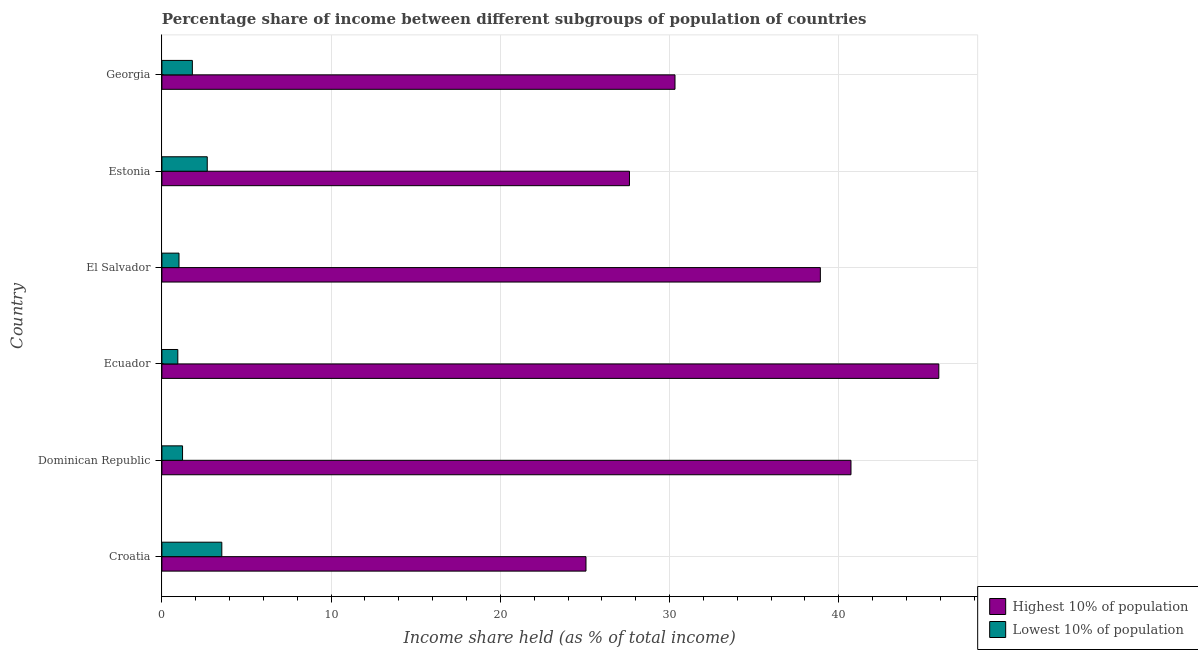How many different coloured bars are there?
Provide a succinct answer. 2. How many groups of bars are there?
Your answer should be very brief. 6. Are the number of bars per tick equal to the number of legend labels?
Keep it short and to the point. Yes. Are the number of bars on each tick of the Y-axis equal?
Provide a short and direct response. Yes. How many bars are there on the 3rd tick from the bottom?
Make the answer very short. 2. What is the label of the 4th group of bars from the top?
Keep it short and to the point. Ecuador. What is the income share held by highest 10% of the population in Estonia?
Keep it short and to the point. 27.63. Across all countries, what is the maximum income share held by highest 10% of the population?
Make the answer very short. 45.91. Across all countries, what is the minimum income share held by lowest 10% of the population?
Your answer should be very brief. 0.94. In which country was the income share held by lowest 10% of the population maximum?
Provide a succinct answer. Croatia. In which country was the income share held by highest 10% of the population minimum?
Ensure brevity in your answer.  Croatia. What is the total income share held by highest 10% of the population in the graph?
Offer a terse response. 208.55. What is the difference between the income share held by lowest 10% of the population in Ecuador and that in El Salvador?
Make the answer very short. -0.07. What is the difference between the income share held by highest 10% of the population in Estonia and the income share held by lowest 10% of the population in El Salvador?
Provide a short and direct response. 26.62. What is the average income share held by lowest 10% of the population per country?
Your response must be concise. 1.86. What is the difference between the income share held by lowest 10% of the population and income share held by highest 10% of the population in El Salvador?
Provide a succinct answer. -37.9. What is the ratio of the income share held by lowest 10% of the population in Ecuador to that in Estonia?
Provide a succinct answer. 0.35. Is the income share held by highest 10% of the population in Croatia less than that in Dominican Republic?
Ensure brevity in your answer.  Yes. Is the difference between the income share held by highest 10% of the population in Croatia and Ecuador greater than the difference between the income share held by lowest 10% of the population in Croatia and Ecuador?
Your answer should be compact. No. What is the difference between the highest and the second highest income share held by highest 10% of the population?
Provide a succinct answer. 5.19. What is the difference between the highest and the lowest income share held by lowest 10% of the population?
Provide a succinct answer. 2.6. Is the sum of the income share held by lowest 10% of the population in Dominican Republic and Georgia greater than the maximum income share held by highest 10% of the population across all countries?
Make the answer very short. No. What does the 2nd bar from the top in Georgia represents?
Provide a short and direct response. Highest 10% of population. What does the 1st bar from the bottom in Dominican Republic represents?
Provide a short and direct response. Highest 10% of population. What is the difference between two consecutive major ticks on the X-axis?
Your answer should be compact. 10. Are the values on the major ticks of X-axis written in scientific E-notation?
Offer a terse response. No. What is the title of the graph?
Provide a succinct answer. Percentage share of income between different subgroups of population of countries. What is the label or title of the X-axis?
Provide a succinct answer. Income share held (as % of total income). What is the Income share held (as % of total income) of Highest 10% of population in Croatia?
Offer a terse response. 25.06. What is the Income share held (as % of total income) in Lowest 10% of population in Croatia?
Offer a terse response. 3.54. What is the Income share held (as % of total income) in Highest 10% of population in Dominican Republic?
Your answer should be compact. 40.72. What is the Income share held (as % of total income) of Lowest 10% of population in Dominican Republic?
Keep it short and to the point. 1.22. What is the Income share held (as % of total income) in Highest 10% of population in Ecuador?
Offer a very short reply. 45.91. What is the Income share held (as % of total income) in Lowest 10% of population in Ecuador?
Your answer should be very brief. 0.94. What is the Income share held (as % of total income) in Highest 10% of population in El Salvador?
Provide a short and direct response. 38.91. What is the Income share held (as % of total income) in Lowest 10% of population in El Salvador?
Provide a short and direct response. 1.01. What is the Income share held (as % of total income) of Highest 10% of population in Estonia?
Your answer should be very brief. 27.63. What is the Income share held (as % of total income) of Lowest 10% of population in Estonia?
Provide a succinct answer. 2.68. What is the Income share held (as % of total income) of Highest 10% of population in Georgia?
Provide a short and direct response. 30.32. Across all countries, what is the maximum Income share held (as % of total income) in Highest 10% of population?
Your response must be concise. 45.91. Across all countries, what is the maximum Income share held (as % of total income) of Lowest 10% of population?
Provide a succinct answer. 3.54. Across all countries, what is the minimum Income share held (as % of total income) in Highest 10% of population?
Provide a succinct answer. 25.06. Across all countries, what is the minimum Income share held (as % of total income) of Lowest 10% of population?
Ensure brevity in your answer.  0.94. What is the total Income share held (as % of total income) of Highest 10% of population in the graph?
Give a very brief answer. 208.55. What is the total Income share held (as % of total income) in Lowest 10% of population in the graph?
Your answer should be compact. 11.19. What is the difference between the Income share held (as % of total income) in Highest 10% of population in Croatia and that in Dominican Republic?
Offer a terse response. -15.66. What is the difference between the Income share held (as % of total income) in Lowest 10% of population in Croatia and that in Dominican Republic?
Offer a very short reply. 2.32. What is the difference between the Income share held (as % of total income) in Highest 10% of population in Croatia and that in Ecuador?
Your response must be concise. -20.85. What is the difference between the Income share held (as % of total income) of Highest 10% of population in Croatia and that in El Salvador?
Give a very brief answer. -13.85. What is the difference between the Income share held (as % of total income) in Lowest 10% of population in Croatia and that in El Salvador?
Your response must be concise. 2.53. What is the difference between the Income share held (as % of total income) of Highest 10% of population in Croatia and that in Estonia?
Provide a succinct answer. -2.57. What is the difference between the Income share held (as % of total income) of Lowest 10% of population in Croatia and that in Estonia?
Offer a very short reply. 0.86. What is the difference between the Income share held (as % of total income) in Highest 10% of population in Croatia and that in Georgia?
Ensure brevity in your answer.  -5.26. What is the difference between the Income share held (as % of total income) of Lowest 10% of population in Croatia and that in Georgia?
Give a very brief answer. 1.74. What is the difference between the Income share held (as % of total income) of Highest 10% of population in Dominican Republic and that in Ecuador?
Your response must be concise. -5.19. What is the difference between the Income share held (as % of total income) of Lowest 10% of population in Dominican Republic and that in Ecuador?
Ensure brevity in your answer.  0.28. What is the difference between the Income share held (as % of total income) of Highest 10% of population in Dominican Republic and that in El Salvador?
Provide a short and direct response. 1.81. What is the difference between the Income share held (as % of total income) in Lowest 10% of population in Dominican Republic and that in El Salvador?
Give a very brief answer. 0.21. What is the difference between the Income share held (as % of total income) in Highest 10% of population in Dominican Republic and that in Estonia?
Your answer should be compact. 13.09. What is the difference between the Income share held (as % of total income) in Lowest 10% of population in Dominican Republic and that in Estonia?
Offer a very short reply. -1.46. What is the difference between the Income share held (as % of total income) in Lowest 10% of population in Dominican Republic and that in Georgia?
Keep it short and to the point. -0.58. What is the difference between the Income share held (as % of total income) of Highest 10% of population in Ecuador and that in El Salvador?
Your answer should be very brief. 7. What is the difference between the Income share held (as % of total income) of Lowest 10% of population in Ecuador and that in El Salvador?
Offer a terse response. -0.07. What is the difference between the Income share held (as % of total income) of Highest 10% of population in Ecuador and that in Estonia?
Provide a succinct answer. 18.28. What is the difference between the Income share held (as % of total income) in Lowest 10% of population in Ecuador and that in Estonia?
Ensure brevity in your answer.  -1.74. What is the difference between the Income share held (as % of total income) of Highest 10% of population in Ecuador and that in Georgia?
Make the answer very short. 15.59. What is the difference between the Income share held (as % of total income) in Lowest 10% of population in Ecuador and that in Georgia?
Provide a short and direct response. -0.86. What is the difference between the Income share held (as % of total income) of Highest 10% of population in El Salvador and that in Estonia?
Ensure brevity in your answer.  11.28. What is the difference between the Income share held (as % of total income) in Lowest 10% of population in El Salvador and that in Estonia?
Offer a terse response. -1.67. What is the difference between the Income share held (as % of total income) of Highest 10% of population in El Salvador and that in Georgia?
Keep it short and to the point. 8.59. What is the difference between the Income share held (as % of total income) in Lowest 10% of population in El Salvador and that in Georgia?
Make the answer very short. -0.79. What is the difference between the Income share held (as % of total income) in Highest 10% of population in Estonia and that in Georgia?
Ensure brevity in your answer.  -2.69. What is the difference between the Income share held (as % of total income) of Highest 10% of population in Croatia and the Income share held (as % of total income) of Lowest 10% of population in Dominican Republic?
Give a very brief answer. 23.84. What is the difference between the Income share held (as % of total income) of Highest 10% of population in Croatia and the Income share held (as % of total income) of Lowest 10% of population in Ecuador?
Provide a short and direct response. 24.12. What is the difference between the Income share held (as % of total income) of Highest 10% of population in Croatia and the Income share held (as % of total income) of Lowest 10% of population in El Salvador?
Keep it short and to the point. 24.05. What is the difference between the Income share held (as % of total income) of Highest 10% of population in Croatia and the Income share held (as % of total income) of Lowest 10% of population in Estonia?
Make the answer very short. 22.38. What is the difference between the Income share held (as % of total income) of Highest 10% of population in Croatia and the Income share held (as % of total income) of Lowest 10% of population in Georgia?
Your answer should be compact. 23.26. What is the difference between the Income share held (as % of total income) of Highest 10% of population in Dominican Republic and the Income share held (as % of total income) of Lowest 10% of population in Ecuador?
Offer a terse response. 39.78. What is the difference between the Income share held (as % of total income) of Highest 10% of population in Dominican Republic and the Income share held (as % of total income) of Lowest 10% of population in El Salvador?
Provide a short and direct response. 39.71. What is the difference between the Income share held (as % of total income) in Highest 10% of population in Dominican Republic and the Income share held (as % of total income) in Lowest 10% of population in Estonia?
Provide a succinct answer. 38.04. What is the difference between the Income share held (as % of total income) in Highest 10% of population in Dominican Republic and the Income share held (as % of total income) in Lowest 10% of population in Georgia?
Make the answer very short. 38.92. What is the difference between the Income share held (as % of total income) of Highest 10% of population in Ecuador and the Income share held (as % of total income) of Lowest 10% of population in El Salvador?
Your answer should be compact. 44.9. What is the difference between the Income share held (as % of total income) of Highest 10% of population in Ecuador and the Income share held (as % of total income) of Lowest 10% of population in Estonia?
Your answer should be very brief. 43.23. What is the difference between the Income share held (as % of total income) of Highest 10% of population in Ecuador and the Income share held (as % of total income) of Lowest 10% of population in Georgia?
Offer a very short reply. 44.11. What is the difference between the Income share held (as % of total income) of Highest 10% of population in El Salvador and the Income share held (as % of total income) of Lowest 10% of population in Estonia?
Offer a very short reply. 36.23. What is the difference between the Income share held (as % of total income) of Highest 10% of population in El Salvador and the Income share held (as % of total income) of Lowest 10% of population in Georgia?
Your answer should be very brief. 37.11. What is the difference between the Income share held (as % of total income) of Highest 10% of population in Estonia and the Income share held (as % of total income) of Lowest 10% of population in Georgia?
Provide a short and direct response. 25.83. What is the average Income share held (as % of total income) in Highest 10% of population per country?
Make the answer very short. 34.76. What is the average Income share held (as % of total income) in Lowest 10% of population per country?
Your answer should be very brief. 1.86. What is the difference between the Income share held (as % of total income) of Highest 10% of population and Income share held (as % of total income) of Lowest 10% of population in Croatia?
Ensure brevity in your answer.  21.52. What is the difference between the Income share held (as % of total income) of Highest 10% of population and Income share held (as % of total income) of Lowest 10% of population in Dominican Republic?
Provide a succinct answer. 39.5. What is the difference between the Income share held (as % of total income) in Highest 10% of population and Income share held (as % of total income) in Lowest 10% of population in Ecuador?
Offer a very short reply. 44.97. What is the difference between the Income share held (as % of total income) of Highest 10% of population and Income share held (as % of total income) of Lowest 10% of population in El Salvador?
Your answer should be very brief. 37.9. What is the difference between the Income share held (as % of total income) in Highest 10% of population and Income share held (as % of total income) in Lowest 10% of population in Estonia?
Provide a succinct answer. 24.95. What is the difference between the Income share held (as % of total income) in Highest 10% of population and Income share held (as % of total income) in Lowest 10% of population in Georgia?
Keep it short and to the point. 28.52. What is the ratio of the Income share held (as % of total income) in Highest 10% of population in Croatia to that in Dominican Republic?
Provide a succinct answer. 0.62. What is the ratio of the Income share held (as % of total income) in Lowest 10% of population in Croatia to that in Dominican Republic?
Provide a short and direct response. 2.9. What is the ratio of the Income share held (as % of total income) of Highest 10% of population in Croatia to that in Ecuador?
Your response must be concise. 0.55. What is the ratio of the Income share held (as % of total income) in Lowest 10% of population in Croatia to that in Ecuador?
Ensure brevity in your answer.  3.77. What is the ratio of the Income share held (as % of total income) in Highest 10% of population in Croatia to that in El Salvador?
Offer a very short reply. 0.64. What is the ratio of the Income share held (as % of total income) of Lowest 10% of population in Croatia to that in El Salvador?
Give a very brief answer. 3.5. What is the ratio of the Income share held (as % of total income) of Highest 10% of population in Croatia to that in Estonia?
Offer a terse response. 0.91. What is the ratio of the Income share held (as % of total income) in Lowest 10% of population in Croatia to that in Estonia?
Give a very brief answer. 1.32. What is the ratio of the Income share held (as % of total income) in Highest 10% of population in Croatia to that in Georgia?
Offer a terse response. 0.83. What is the ratio of the Income share held (as % of total income) in Lowest 10% of population in Croatia to that in Georgia?
Keep it short and to the point. 1.97. What is the ratio of the Income share held (as % of total income) in Highest 10% of population in Dominican Republic to that in Ecuador?
Provide a succinct answer. 0.89. What is the ratio of the Income share held (as % of total income) in Lowest 10% of population in Dominican Republic to that in Ecuador?
Offer a terse response. 1.3. What is the ratio of the Income share held (as % of total income) in Highest 10% of population in Dominican Republic to that in El Salvador?
Give a very brief answer. 1.05. What is the ratio of the Income share held (as % of total income) in Lowest 10% of population in Dominican Republic to that in El Salvador?
Provide a short and direct response. 1.21. What is the ratio of the Income share held (as % of total income) of Highest 10% of population in Dominican Republic to that in Estonia?
Offer a terse response. 1.47. What is the ratio of the Income share held (as % of total income) of Lowest 10% of population in Dominican Republic to that in Estonia?
Offer a very short reply. 0.46. What is the ratio of the Income share held (as % of total income) in Highest 10% of population in Dominican Republic to that in Georgia?
Provide a succinct answer. 1.34. What is the ratio of the Income share held (as % of total income) of Lowest 10% of population in Dominican Republic to that in Georgia?
Make the answer very short. 0.68. What is the ratio of the Income share held (as % of total income) in Highest 10% of population in Ecuador to that in El Salvador?
Your answer should be very brief. 1.18. What is the ratio of the Income share held (as % of total income) in Lowest 10% of population in Ecuador to that in El Salvador?
Offer a very short reply. 0.93. What is the ratio of the Income share held (as % of total income) of Highest 10% of population in Ecuador to that in Estonia?
Your answer should be very brief. 1.66. What is the ratio of the Income share held (as % of total income) of Lowest 10% of population in Ecuador to that in Estonia?
Offer a very short reply. 0.35. What is the ratio of the Income share held (as % of total income) in Highest 10% of population in Ecuador to that in Georgia?
Your answer should be compact. 1.51. What is the ratio of the Income share held (as % of total income) of Lowest 10% of population in Ecuador to that in Georgia?
Your response must be concise. 0.52. What is the ratio of the Income share held (as % of total income) in Highest 10% of population in El Salvador to that in Estonia?
Ensure brevity in your answer.  1.41. What is the ratio of the Income share held (as % of total income) in Lowest 10% of population in El Salvador to that in Estonia?
Provide a succinct answer. 0.38. What is the ratio of the Income share held (as % of total income) in Highest 10% of population in El Salvador to that in Georgia?
Ensure brevity in your answer.  1.28. What is the ratio of the Income share held (as % of total income) in Lowest 10% of population in El Salvador to that in Georgia?
Offer a terse response. 0.56. What is the ratio of the Income share held (as % of total income) in Highest 10% of population in Estonia to that in Georgia?
Make the answer very short. 0.91. What is the ratio of the Income share held (as % of total income) in Lowest 10% of population in Estonia to that in Georgia?
Your answer should be compact. 1.49. What is the difference between the highest and the second highest Income share held (as % of total income) of Highest 10% of population?
Offer a very short reply. 5.19. What is the difference between the highest and the second highest Income share held (as % of total income) in Lowest 10% of population?
Offer a terse response. 0.86. What is the difference between the highest and the lowest Income share held (as % of total income) in Highest 10% of population?
Offer a terse response. 20.85. What is the difference between the highest and the lowest Income share held (as % of total income) in Lowest 10% of population?
Keep it short and to the point. 2.6. 